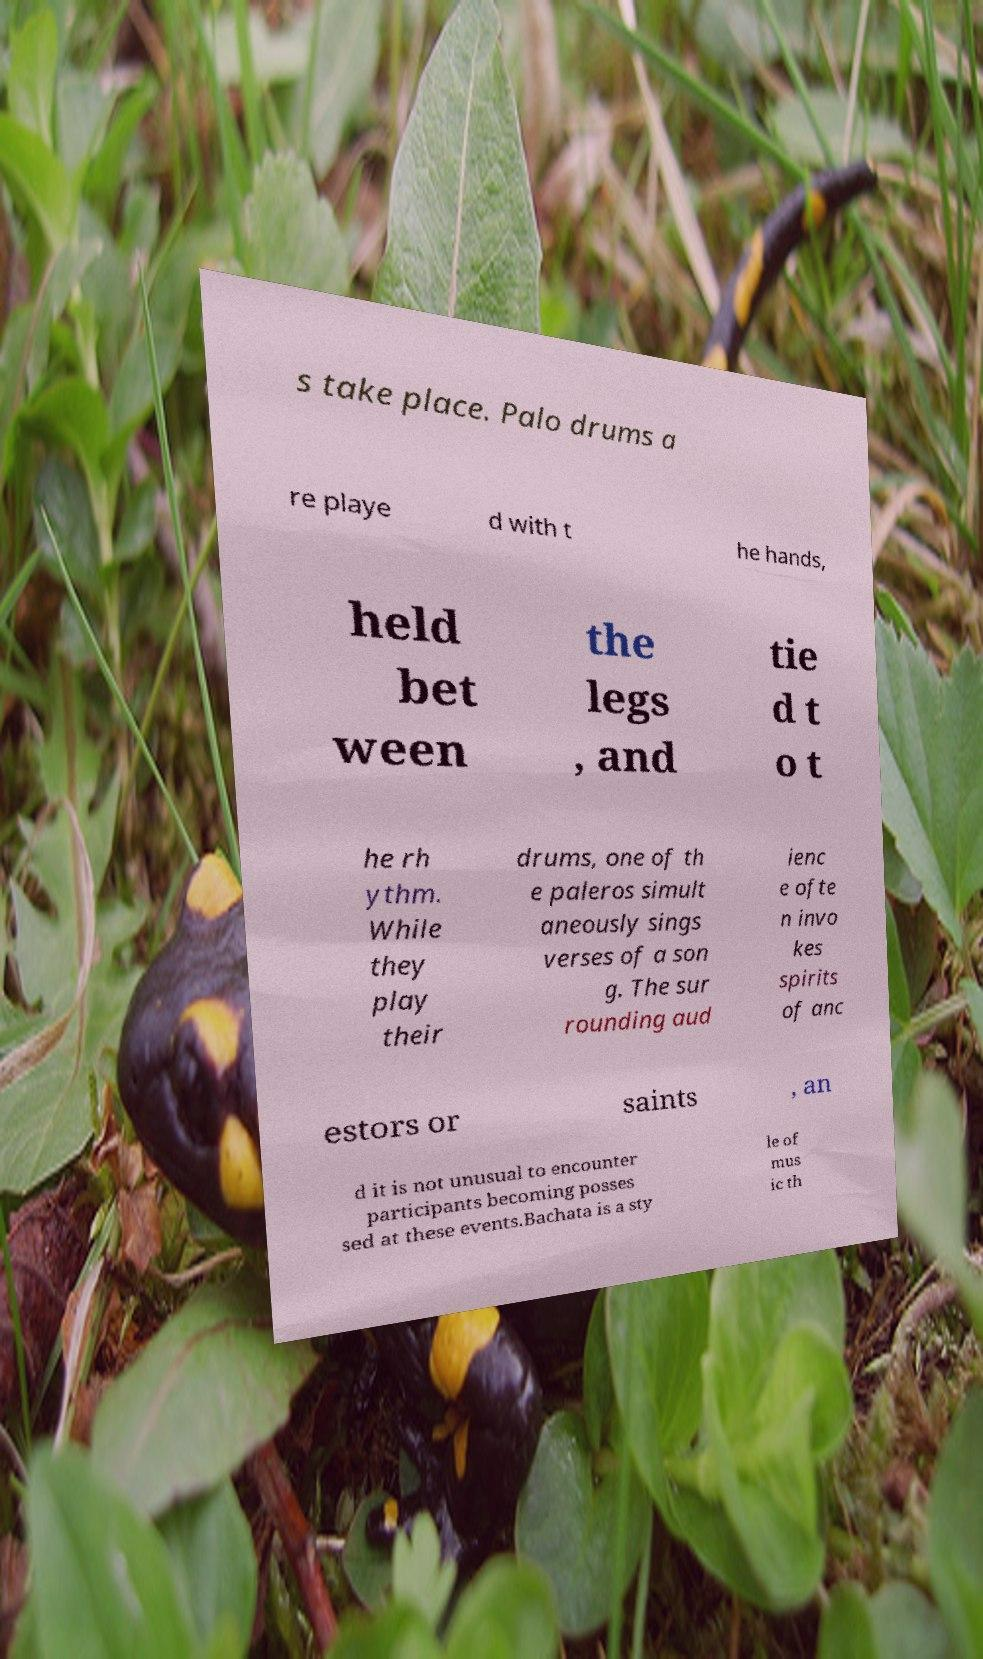Please read and relay the text visible in this image. What does it say? s take place. Palo drums a re playe d with t he hands, held bet ween the legs , and tie d t o t he rh ythm. While they play their drums, one of th e paleros simult aneously sings verses of a son g. The sur rounding aud ienc e ofte n invo kes spirits of anc estors or saints , an d it is not unusual to encounter participants becoming posses sed at these events.Bachata is a sty le of mus ic th 